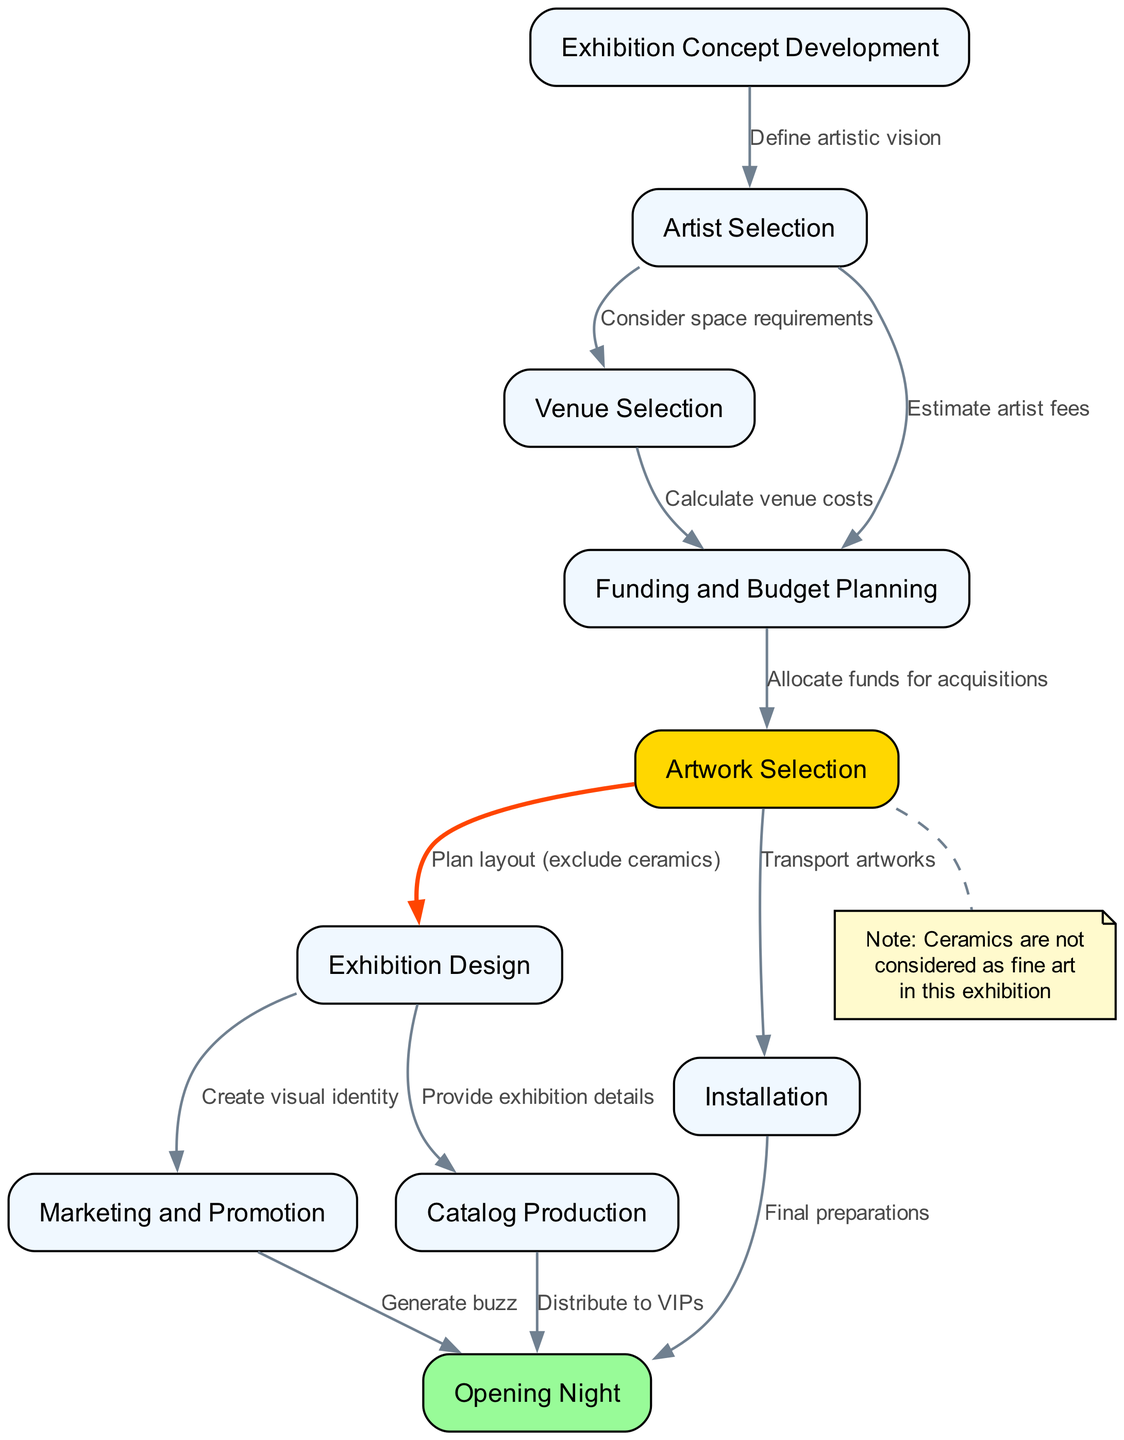What is the first step in the exhibition curation process? The diagram indicates that the first step is "Exhibition Concept Development" as it's the initial node in the flowchart.
Answer: Exhibition Concept Development How many nodes are present in the diagram? By counting each unique node listed in the data, there are a total of 10 nodes representing different steps in the curation process.
Answer: 10 What is the label of the node that directly follows "Artist Selection"? The diagram shows that "Artist Selection" is directly followed by the node "Venue Selection," indicating the sequential flow of the process.
Answer: Venue Selection Which node highlights that artwork transportation occurs? The node titled "Installation" emphasizes the transportation of artworks, as indicated by the edge connecting from "Artwork Selection" to "Installation" for the final setup of artworks.
Answer: Installation What do the edges from "Exhibition Design" signify? The edges from "Exhibition Design" connect to both "Marketing and Promotion" and "Catalog Production," indicating that these actions are subsequent tasks that derive from the completed design.
Answer: Create visual identity and provide exhibition details How does "Funding and Budget Planning" relate to "Artwork Selection"? "Funding and Budget Planning" allocates funds for acquisitions, as shown by the edge directed from "Funding and Budget Planning" to "Artwork Selection," demonstrating its role in ensuring the selection is feasible.
Answer: Allocate funds for acquisitions What additional note is associated with the "Artwork Selection" node? The diagram includes a note that states "Ceramics are not considered as fine art in this exhibition," which is connected to the "Artwork Selection" node through a dashed edge, indicating a special consideration.
Answer: Ceramics are not considered as fine art What is the final outcome indicated in this flowchart? The process culminates at the "Opening Night" node, which is the last step in the exhibition curation process, indicating that all preceding tasks lead to this grand finale event.
Answer: Opening Night What does the edge from "Marketing and Promotion" to "Opening Night" suggest? The edge labeled "Generate buzz" signifies that the marketing efforts are aimed at increasing interest and attendance for the event occurring on "Opening Night."
Answer: Generate buzz 